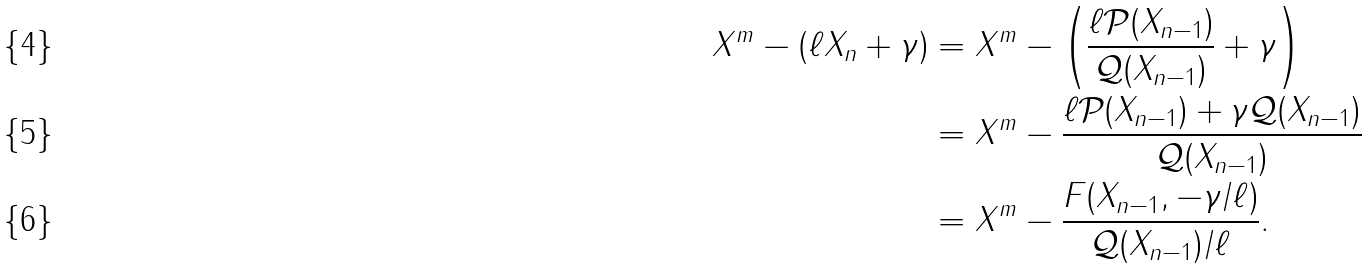Convert formula to latex. <formula><loc_0><loc_0><loc_500><loc_500>X ^ { m } - ( \ell X _ { n } + \gamma ) & = X ^ { m } - \left ( \frac { \ell \mathcal { P } ( X _ { n - 1 } ) } { \mathcal { Q } ( X _ { n - 1 } ) } + \gamma \right ) \\ & = X ^ { m } - \frac { \ell \mathcal { P } ( X _ { n - 1 } ) + \gamma \mathcal { Q } ( X _ { n - 1 } ) } { \mathcal { Q } ( X _ { n - 1 } ) } \\ & = X ^ { m } - \frac { F ( X _ { n - 1 } , - \gamma / \ell ) } { \mathcal { Q } ( X _ { n - 1 } ) / \ell } .</formula> 